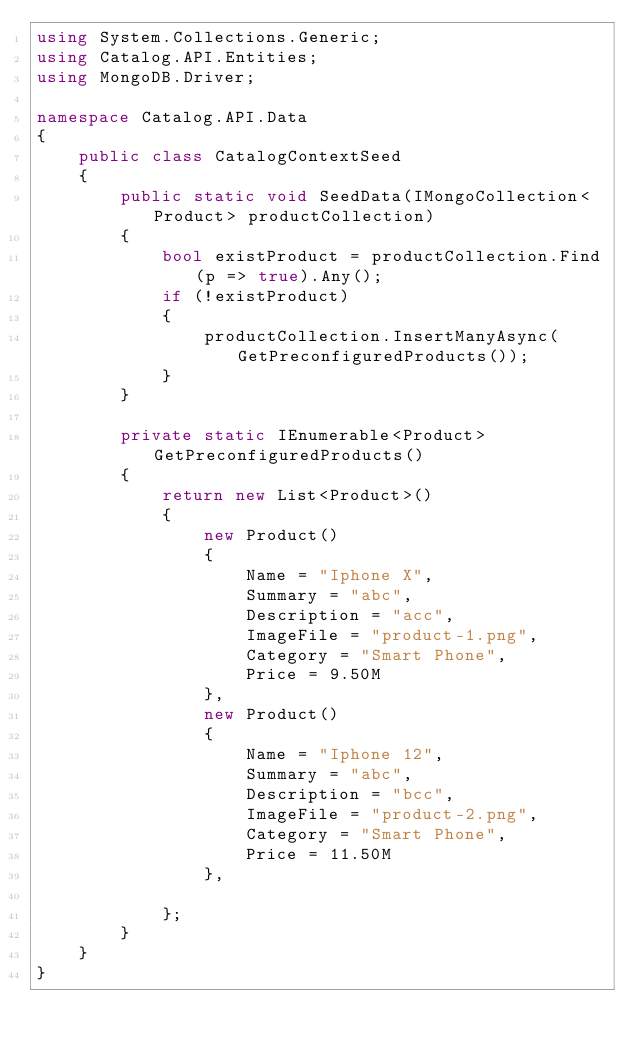<code> <loc_0><loc_0><loc_500><loc_500><_C#_>using System.Collections.Generic;
using Catalog.API.Entities;
using MongoDB.Driver;

namespace Catalog.API.Data
{
    public class CatalogContextSeed
    {
        public static void SeedData(IMongoCollection<Product> productCollection)
        {
            bool existProduct = productCollection.Find(p => true).Any();
            if (!existProduct)
            {
                productCollection.InsertManyAsync(GetPreconfiguredProducts());
            }
        }

        private static IEnumerable<Product> GetPreconfiguredProducts()
        {
            return new List<Product>()
            {
                new Product()
                {
                    Name = "Iphone X",
                    Summary = "abc",
                    Description = "acc",
                    ImageFile = "product-1.png",
                    Category = "Smart Phone",
                    Price = 9.50M
                },
                new Product()
                {
                    Name = "Iphone 12",
                    Summary = "abc",
                    Description = "bcc",
                    ImageFile = "product-2.png",
                    Category = "Smart Phone",
                    Price = 11.50M
                },
                
            };
        }
    }
}</code> 